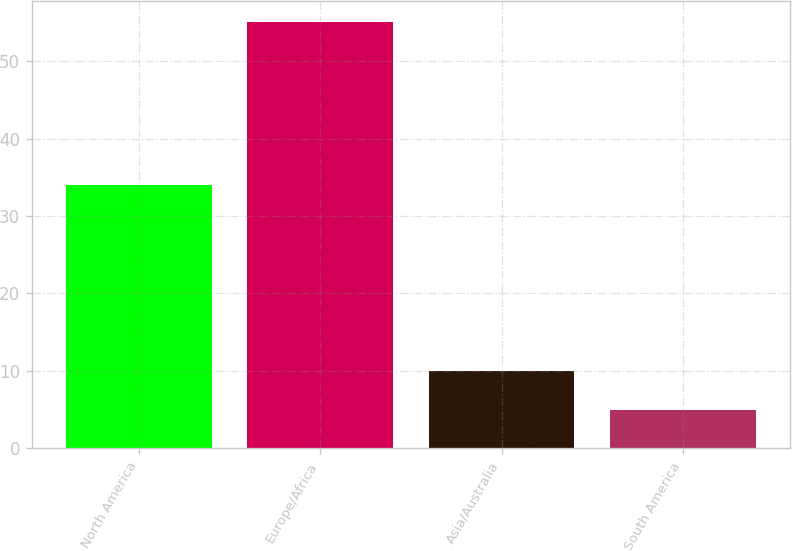Convert chart to OTSL. <chart><loc_0><loc_0><loc_500><loc_500><bar_chart><fcel>North America<fcel>Europe/Africa<fcel>Asia/Australia<fcel>South America<nl><fcel>34<fcel>55<fcel>10<fcel>5<nl></chart> 